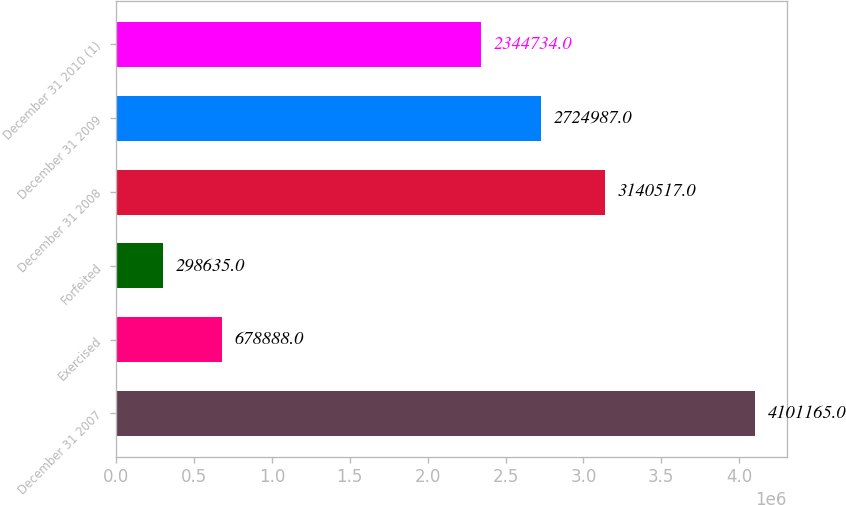Convert chart to OTSL. <chart><loc_0><loc_0><loc_500><loc_500><bar_chart><fcel>December 31 2007<fcel>Exercised<fcel>Forfeited<fcel>December 31 2008<fcel>December 31 2009<fcel>December 31 2010 (1)<nl><fcel>4.10116e+06<fcel>678888<fcel>298635<fcel>3.14052e+06<fcel>2.72499e+06<fcel>2.34473e+06<nl></chart> 